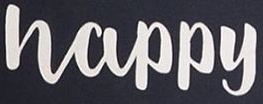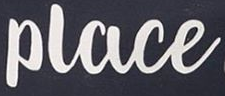Transcribe the words shown in these images in order, separated by a semicolon. Happy; Place 